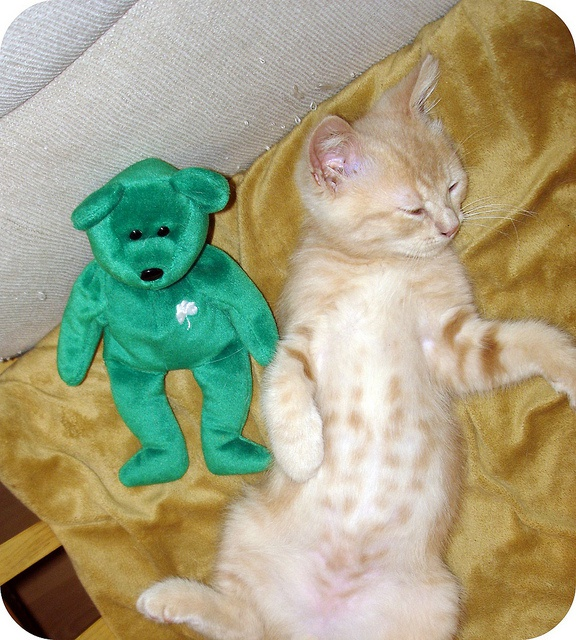Describe the objects in this image and their specific colors. I can see cat in white, lightgray, and tan tones, couch in white, darkgray, lightgray, and gray tones, and teddy bear in white, turquoise, and teal tones in this image. 